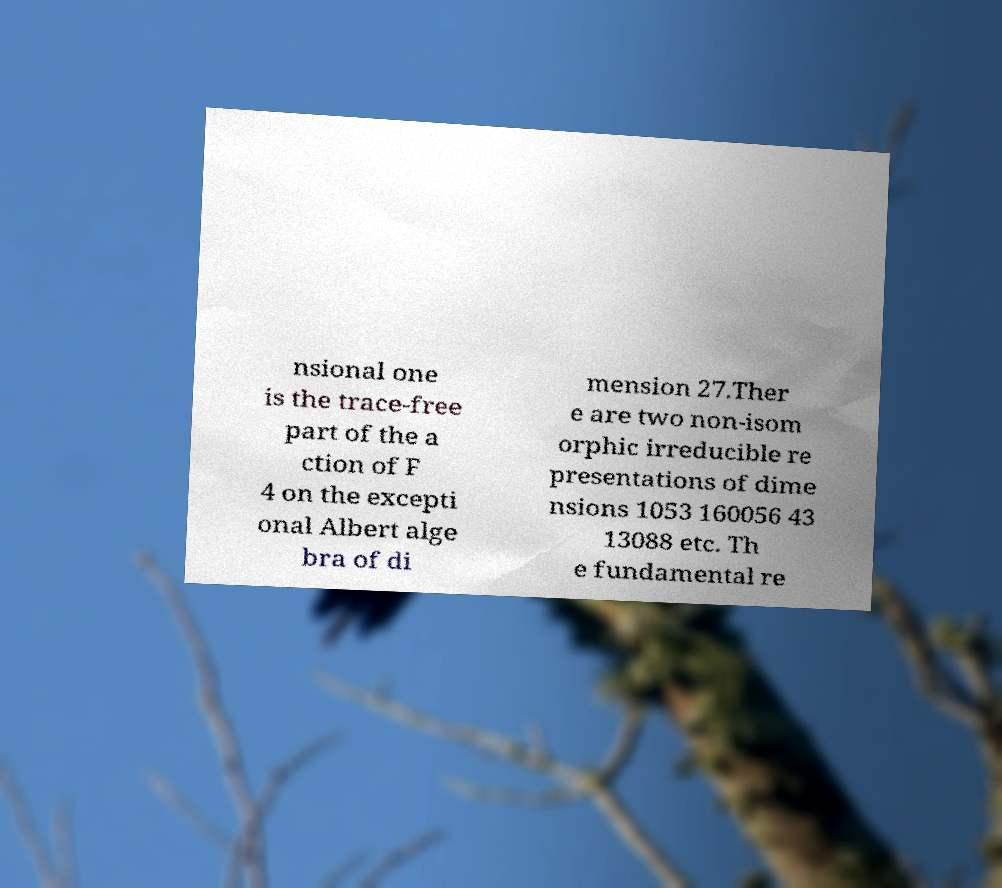Could you extract and type out the text from this image? nsional one is the trace-free part of the a ction of F 4 on the excepti onal Albert alge bra of di mension 27.Ther e are two non-isom orphic irreducible re presentations of dime nsions 1053 160056 43 13088 etc. Th e fundamental re 